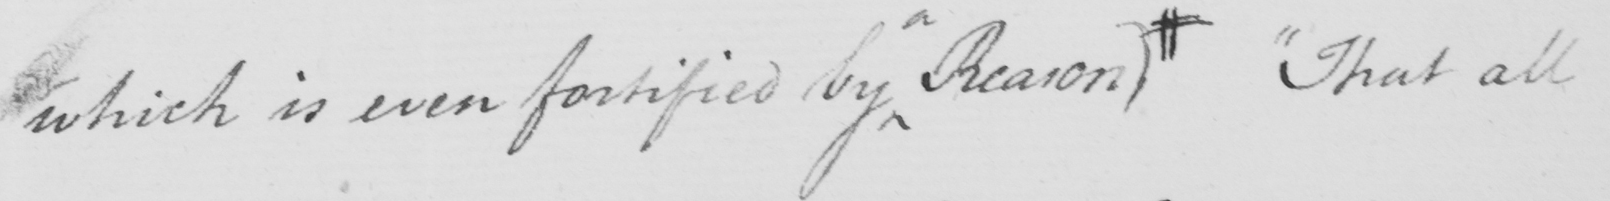What does this handwritten line say? which is even fortified by Reason )  #  " That all 